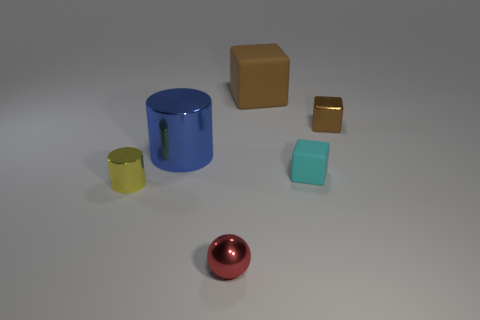Is there any other thing that has the same shape as the tiny red object?
Offer a very short reply. No. What is the tiny object that is on the right side of the brown rubber object and in front of the blue thing made of?
Give a very brief answer. Rubber. What is the color of the matte object that is the same size as the red shiny object?
Give a very brief answer. Cyan. Does the blue cylinder have the same material as the tiny object that is behind the blue shiny cylinder?
Offer a very short reply. Yes. What number of other objects are there of the same size as the yellow shiny thing?
Your answer should be compact. 3. There is a matte object that is in front of the big object right of the red metal object; is there a small red ball behind it?
Give a very brief answer. No. What is the size of the blue cylinder?
Your response must be concise. Large. There is a brown cube to the left of the small brown cube; how big is it?
Your answer should be compact. Large. There is a shiny cylinder right of the yellow object; is it the same size as the tiny yellow metal thing?
Your answer should be very brief. No. Are there any other things that are the same color as the large metal object?
Your response must be concise. No. 